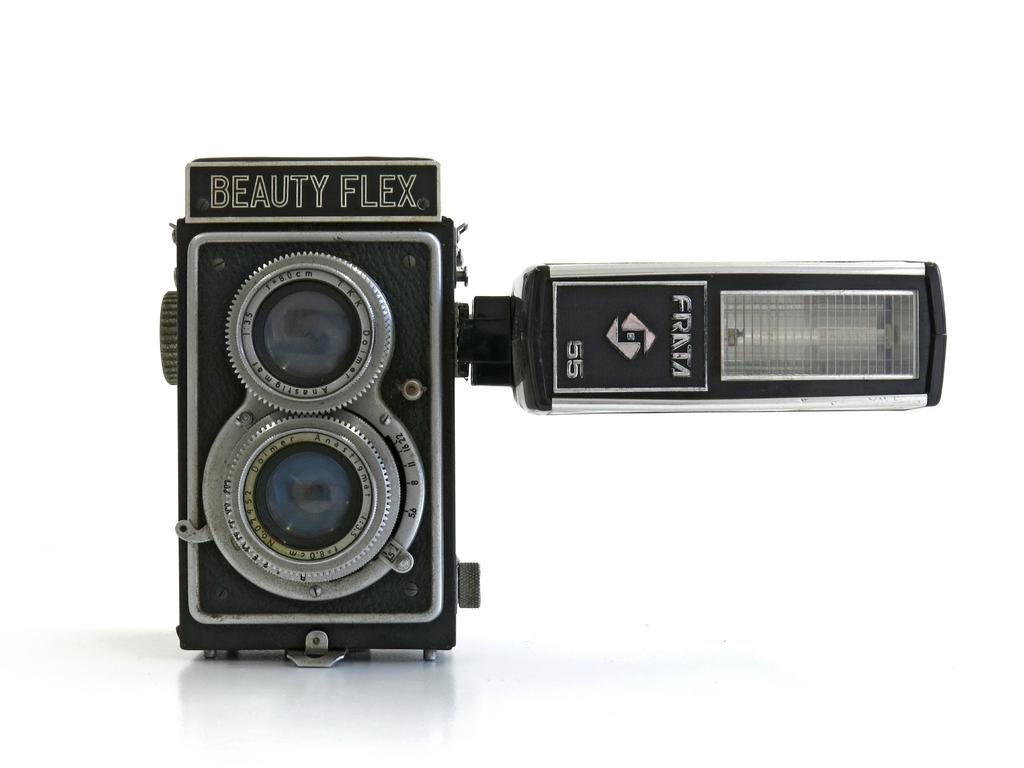What does the camera say above the lens?
Provide a short and direct response. Beauty flex. 